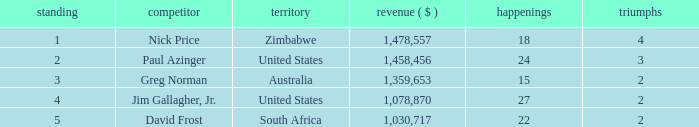How many events have earnings less than 1,030,717? 0.0. 